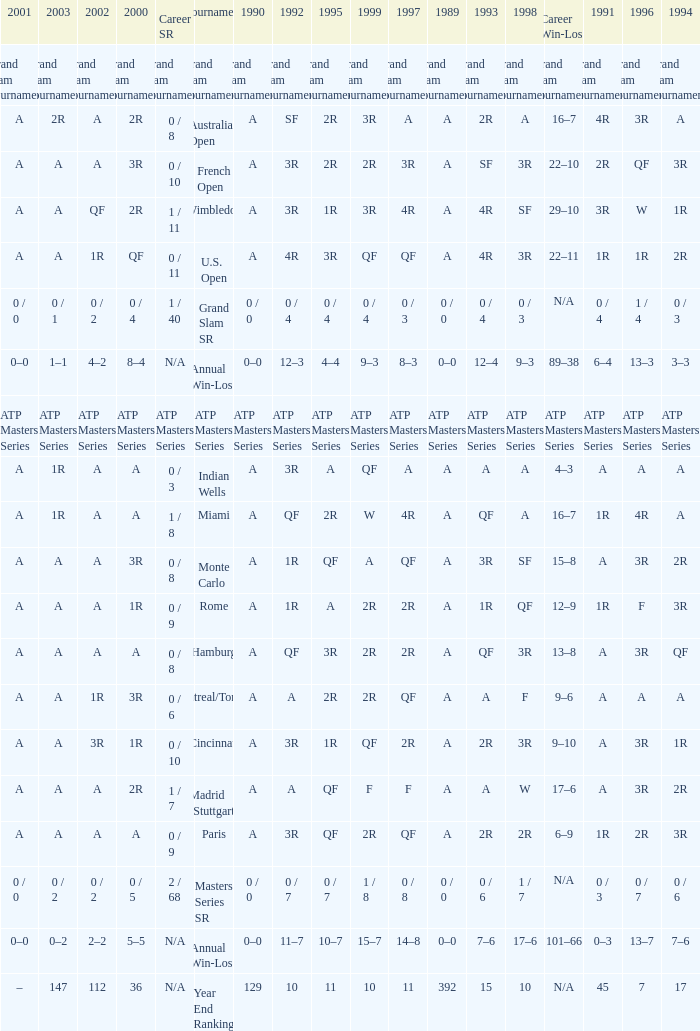What were the career sr values for a in 1980 and for f in 1997? 1 / 7. 